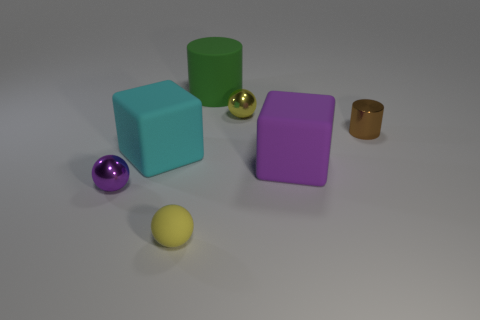Subtract all small metallic balls. How many balls are left? 1 Subtract all cyan cubes. How many cubes are left? 1 Add 2 brown matte cubes. How many objects exist? 9 Subtract all cylinders. How many objects are left? 5 Subtract 2 blocks. How many blocks are left? 0 Subtract all green cylinders. Subtract all brown blocks. How many cylinders are left? 1 Subtract all yellow spheres. How many cyan cylinders are left? 0 Subtract all small things. Subtract all yellow metallic objects. How many objects are left? 2 Add 4 cylinders. How many cylinders are left? 6 Add 5 large purple blocks. How many large purple blocks exist? 6 